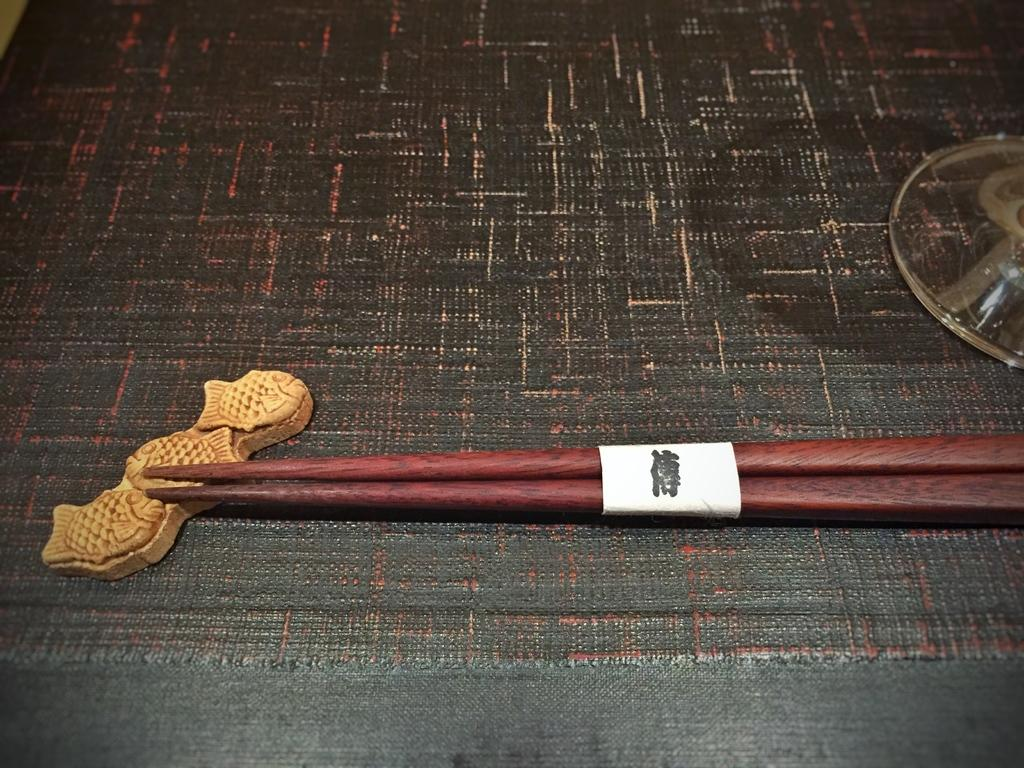What type of objects are present in the image? There are wooden sticks in the image. Where are the wooden sticks located? The wooden sticks are on a carpet. What color is the sweater worn by the person in the image? There is no person or sweater present in the image; it only features wooden sticks on a carpet. 